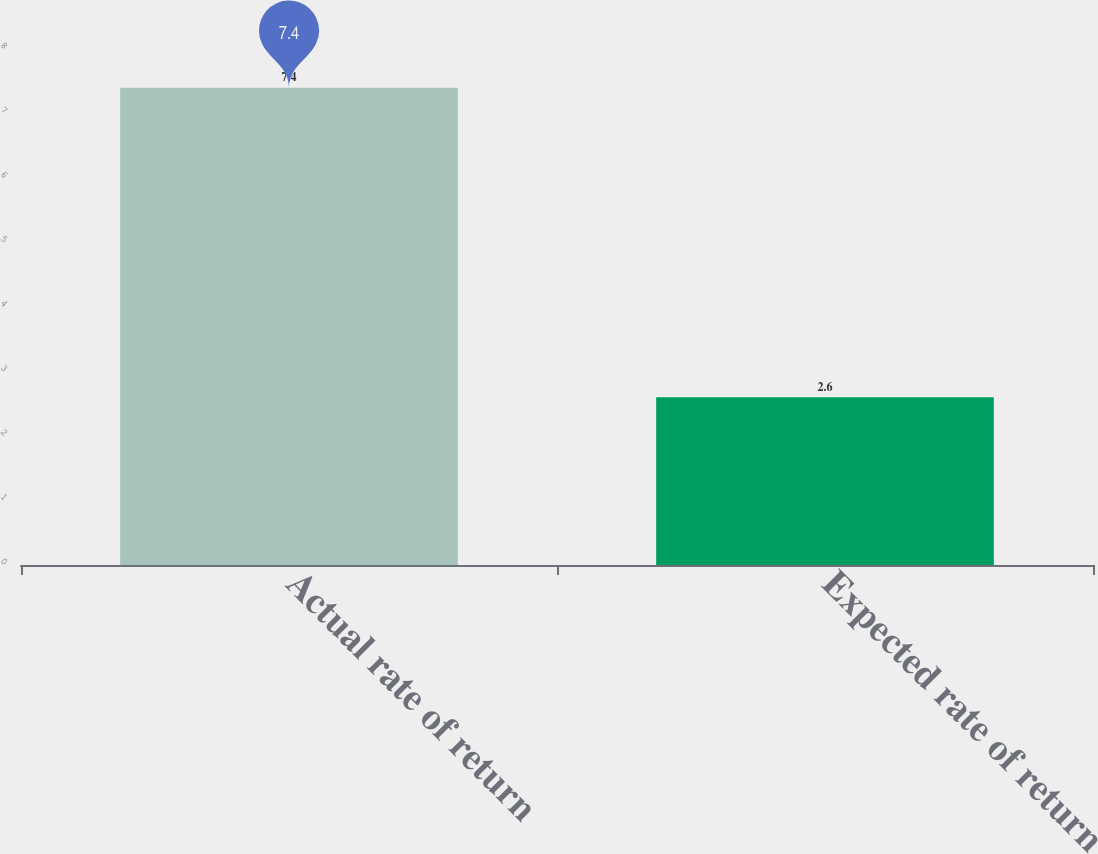<chart> <loc_0><loc_0><loc_500><loc_500><bar_chart><fcel>Actual rate of return<fcel>Expected rate of return<nl><fcel>7.4<fcel>2.6<nl></chart> 